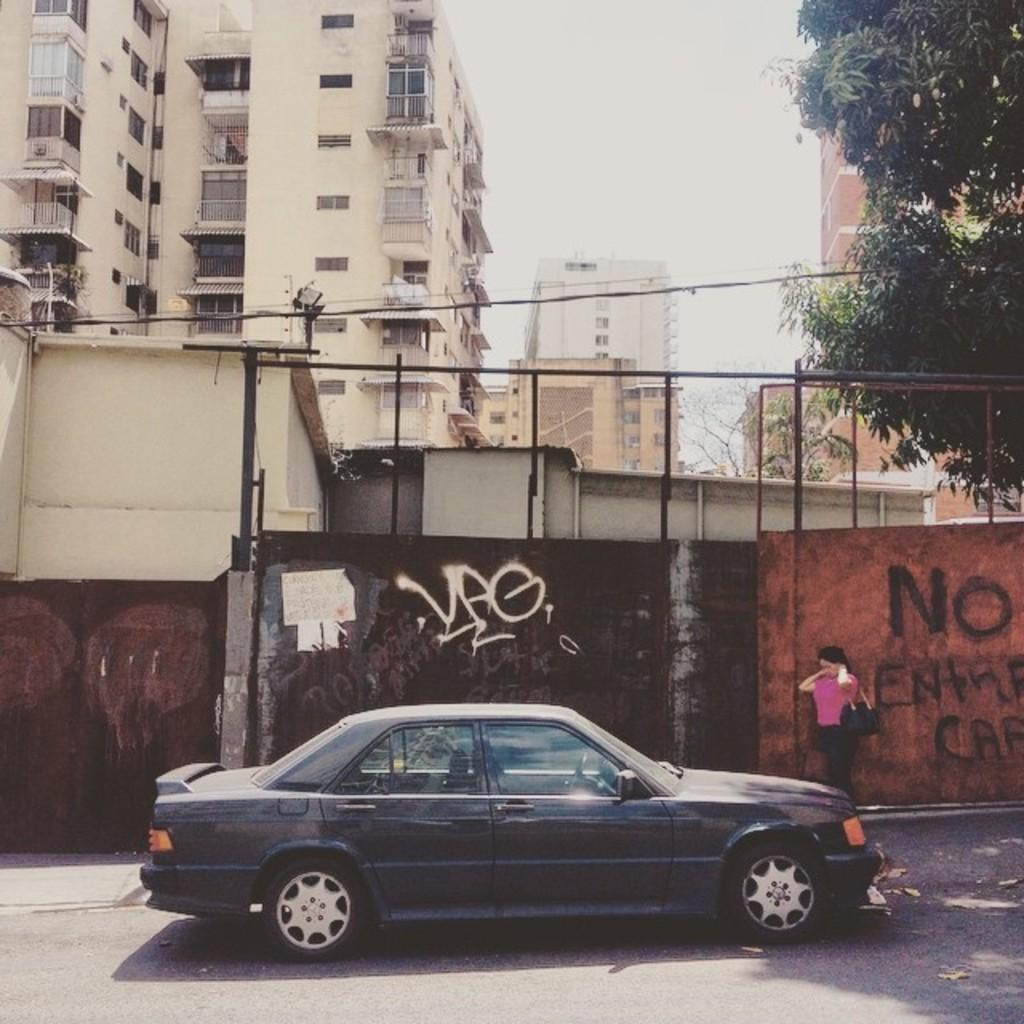Who or what is present in the image? There is a person in the image. What can be seen on the road in the image? There is a car on the road in the image. What is on the wall in the image? There is graffiti on the wall in the image. What type of structure is visible in the image? There is a building in the image. What type of vegetation is present in the image? There is a tree in the image. What does the wall say in the image? The image does not show any text or words on the wall, only graffiti. What type of voice can be heard coming from the tree in the image? There is no voice or sound coming from the tree in the image. 